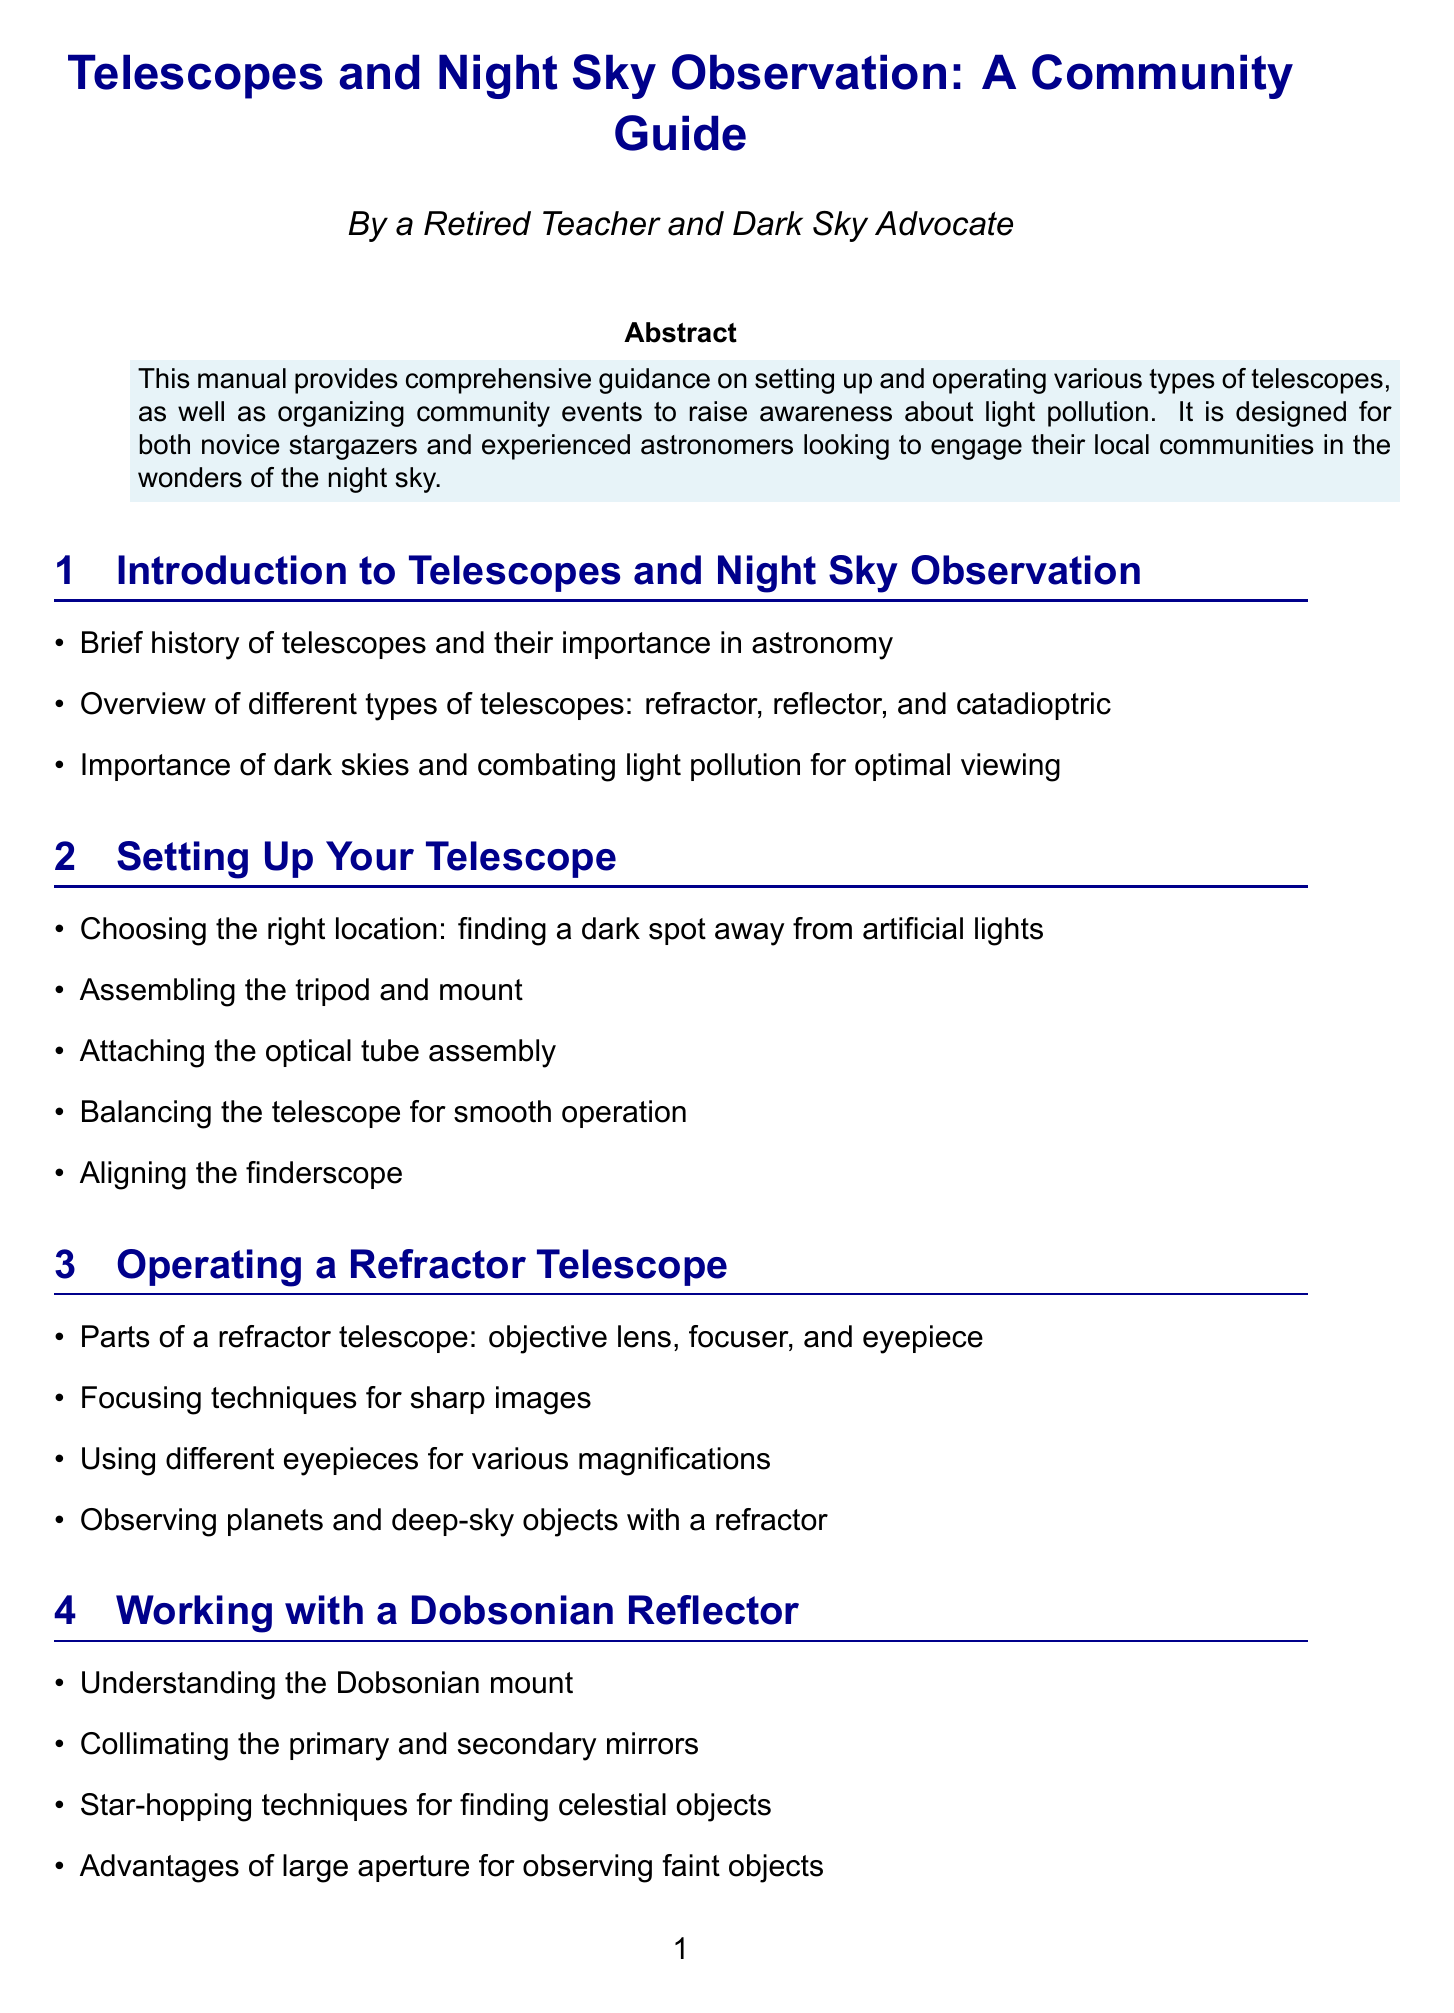What are the three main types of telescopes? The document lists refractor, reflector, and catadioptric as the three main types of telescopes.
Answer: refractor, reflector, catadioptric What is crucial for optimal viewing of the night sky? The document emphasizes the importance of dark skies and combating light pollution for optimal viewing.
Answer: dark skies and combating light pollution What is one technique mentioned for finding celestial objects? The document mentions star-hopping techniques as a way to find celestial objects when working with a Dobsonian reflector.
Answer: star-hopping techniques What is the purpose of using filters in night sky observation? The document lists lunar, planetary, and light pollution reduction filters as tools used in observing the night sky.
Answer: lunar, planetary, and light pollution reduction filters Which book is recommended for further learning about astronomy? The document highlights 'Turn Left at Orion' by Guy Consolmagno and Dan M. Davis as a recommended book.
Answer: 'Turn Left at Orion' How should you protect your night vision when observing? According to the manual, protecting night vision can be done with red flashlights.
Answer: red flashlights What event is mentioned for community engagement? The manual discusses organizing community star parties as a means for engagement.
Answer: community star parties What should you use to navigate the stars? The document mentions star charts and planispheres for navigation of the night sky.
Answer: star charts and planispheres 